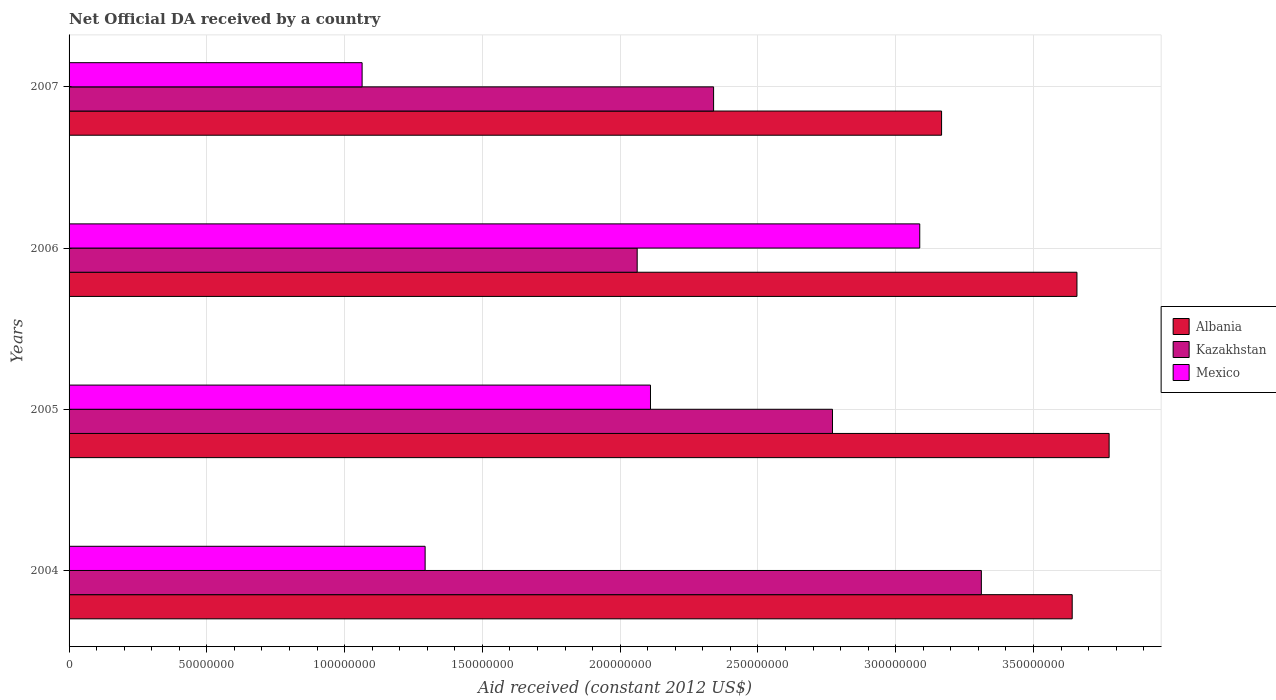Are the number of bars on each tick of the Y-axis equal?
Keep it short and to the point. Yes. In how many cases, is the number of bars for a given year not equal to the number of legend labels?
Provide a short and direct response. 0. What is the net official development assistance aid received in Albania in 2005?
Keep it short and to the point. 3.77e+08. Across all years, what is the maximum net official development assistance aid received in Mexico?
Provide a short and direct response. 3.09e+08. Across all years, what is the minimum net official development assistance aid received in Kazakhstan?
Provide a short and direct response. 2.06e+08. In which year was the net official development assistance aid received in Albania maximum?
Ensure brevity in your answer.  2005. What is the total net official development assistance aid received in Kazakhstan in the graph?
Your answer should be very brief. 1.05e+09. What is the difference between the net official development assistance aid received in Albania in 2006 and that in 2007?
Ensure brevity in your answer.  4.91e+07. What is the difference between the net official development assistance aid received in Kazakhstan in 2004 and the net official development assistance aid received in Mexico in 2005?
Provide a succinct answer. 1.20e+08. What is the average net official development assistance aid received in Kazakhstan per year?
Give a very brief answer. 2.62e+08. In the year 2004, what is the difference between the net official development assistance aid received in Albania and net official development assistance aid received in Mexico?
Offer a terse response. 2.35e+08. What is the ratio of the net official development assistance aid received in Mexico in 2006 to that in 2007?
Make the answer very short. 2.9. Is the net official development assistance aid received in Mexico in 2004 less than that in 2005?
Give a very brief answer. Yes. Is the difference between the net official development assistance aid received in Albania in 2005 and 2007 greater than the difference between the net official development assistance aid received in Mexico in 2005 and 2007?
Provide a short and direct response. No. What is the difference between the highest and the second highest net official development assistance aid received in Albania?
Keep it short and to the point. 1.17e+07. What is the difference between the highest and the lowest net official development assistance aid received in Albania?
Keep it short and to the point. 6.08e+07. In how many years, is the net official development assistance aid received in Albania greater than the average net official development assistance aid received in Albania taken over all years?
Offer a terse response. 3. Is the sum of the net official development assistance aid received in Mexico in 2004 and 2006 greater than the maximum net official development assistance aid received in Kazakhstan across all years?
Provide a short and direct response. Yes. What does the 3rd bar from the top in 2004 represents?
Provide a short and direct response. Albania. What does the 2nd bar from the bottom in 2006 represents?
Your answer should be very brief. Kazakhstan. How many bars are there?
Provide a succinct answer. 12. What is the difference between two consecutive major ticks on the X-axis?
Keep it short and to the point. 5.00e+07. Are the values on the major ticks of X-axis written in scientific E-notation?
Offer a very short reply. No. How many legend labels are there?
Offer a terse response. 3. What is the title of the graph?
Your answer should be very brief. Net Official DA received by a country. What is the label or title of the X-axis?
Provide a succinct answer. Aid received (constant 2012 US$). What is the Aid received (constant 2012 US$) of Albania in 2004?
Keep it short and to the point. 3.64e+08. What is the Aid received (constant 2012 US$) of Kazakhstan in 2004?
Your answer should be very brief. 3.31e+08. What is the Aid received (constant 2012 US$) in Mexico in 2004?
Ensure brevity in your answer.  1.29e+08. What is the Aid received (constant 2012 US$) of Albania in 2005?
Provide a short and direct response. 3.77e+08. What is the Aid received (constant 2012 US$) of Kazakhstan in 2005?
Offer a terse response. 2.77e+08. What is the Aid received (constant 2012 US$) in Mexico in 2005?
Your response must be concise. 2.11e+08. What is the Aid received (constant 2012 US$) in Albania in 2006?
Your answer should be very brief. 3.66e+08. What is the Aid received (constant 2012 US$) of Kazakhstan in 2006?
Provide a short and direct response. 2.06e+08. What is the Aid received (constant 2012 US$) of Mexico in 2006?
Keep it short and to the point. 3.09e+08. What is the Aid received (constant 2012 US$) of Albania in 2007?
Make the answer very short. 3.17e+08. What is the Aid received (constant 2012 US$) of Kazakhstan in 2007?
Your answer should be compact. 2.34e+08. What is the Aid received (constant 2012 US$) in Mexico in 2007?
Give a very brief answer. 1.06e+08. Across all years, what is the maximum Aid received (constant 2012 US$) in Albania?
Give a very brief answer. 3.77e+08. Across all years, what is the maximum Aid received (constant 2012 US$) in Kazakhstan?
Provide a short and direct response. 3.31e+08. Across all years, what is the maximum Aid received (constant 2012 US$) in Mexico?
Your answer should be very brief. 3.09e+08. Across all years, what is the minimum Aid received (constant 2012 US$) of Albania?
Provide a short and direct response. 3.17e+08. Across all years, what is the minimum Aid received (constant 2012 US$) of Kazakhstan?
Give a very brief answer. 2.06e+08. Across all years, what is the minimum Aid received (constant 2012 US$) in Mexico?
Provide a short and direct response. 1.06e+08. What is the total Aid received (constant 2012 US$) of Albania in the graph?
Offer a very short reply. 1.42e+09. What is the total Aid received (constant 2012 US$) of Kazakhstan in the graph?
Provide a succinct answer. 1.05e+09. What is the total Aid received (constant 2012 US$) of Mexico in the graph?
Keep it short and to the point. 7.55e+08. What is the difference between the Aid received (constant 2012 US$) of Albania in 2004 and that in 2005?
Offer a very short reply. -1.34e+07. What is the difference between the Aid received (constant 2012 US$) in Kazakhstan in 2004 and that in 2005?
Offer a very short reply. 5.40e+07. What is the difference between the Aid received (constant 2012 US$) of Mexico in 2004 and that in 2005?
Give a very brief answer. -8.18e+07. What is the difference between the Aid received (constant 2012 US$) of Albania in 2004 and that in 2006?
Make the answer very short. -1.72e+06. What is the difference between the Aid received (constant 2012 US$) in Kazakhstan in 2004 and that in 2006?
Provide a succinct answer. 1.25e+08. What is the difference between the Aid received (constant 2012 US$) of Mexico in 2004 and that in 2006?
Offer a very short reply. -1.80e+08. What is the difference between the Aid received (constant 2012 US$) in Albania in 2004 and that in 2007?
Offer a very short reply. 4.74e+07. What is the difference between the Aid received (constant 2012 US$) in Kazakhstan in 2004 and that in 2007?
Keep it short and to the point. 9.72e+07. What is the difference between the Aid received (constant 2012 US$) of Mexico in 2004 and that in 2007?
Give a very brief answer. 2.29e+07. What is the difference between the Aid received (constant 2012 US$) of Albania in 2005 and that in 2006?
Provide a succinct answer. 1.17e+07. What is the difference between the Aid received (constant 2012 US$) of Kazakhstan in 2005 and that in 2006?
Provide a short and direct response. 7.09e+07. What is the difference between the Aid received (constant 2012 US$) of Mexico in 2005 and that in 2006?
Ensure brevity in your answer.  -9.77e+07. What is the difference between the Aid received (constant 2012 US$) in Albania in 2005 and that in 2007?
Offer a terse response. 6.08e+07. What is the difference between the Aid received (constant 2012 US$) of Kazakhstan in 2005 and that in 2007?
Provide a succinct answer. 4.32e+07. What is the difference between the Aid received (constant 2012 US$) in Mexico in 2005 and that in 2007?
Your answer should be compact. 1.05e+08. What is the difference between the Aid received (constant 2012 US$) of Albania in 2006 and that in 2007?
Give a very brief answer. 4.91e+07. What is the difference between the Aid received (constant 2012 US$) of Kazakhstan in 2006 and that in 2007?
Provide a succinct answer. -2.77e+07. What is the difference between the Aid received (constant 2012 US$) in Mexico in 2006 and that in 2007?
Keep it short and to the point. 2.02e+08. What is the difference between the Aid received (constant 2012 US$) of Albania in 2004 and the Aid received (constant 2012 US$) of Kazakhstan in 2005?
Your answer should be compact. 8.70e+07. What is the difference between the Aid received (constant 2012 US$) in Albania in 2004 and the Aid received (constant 2012 US$) in Mexico in 2005?
Provide a succinct answer. 1.53e+08. What is the difference between the Aid received (constant 2012 US$) of Kazakhstan in 2004 and the Aid received (constant 2012 US$) of Mexico in 2005?
Provide a short and direct response. 1.20e+08. What is the difference between the Aid received (constant 2012 US$) of Albania in 2004 and the Aid received (constant 2012 US$) of Kazakhstan in 2006?
Your answer should be very brief. 1.58e+08. What is the difference between the Aid received (constant 2012 US$) of Albania in 2004 and the Aid received (constant 2012 US$) of Mexico in 2006?
Your answer should be compact. 5.53e+07. What is the difference between the Aid received (constant 2012 US$) of Kazakhstan in 2004 and the Aid received (constant 2012 US$) of Mexico in 2006?
Your answer should be compact. 2.24e+07. What is the difference between the Aid received (constant 2012 US$) in Albania in 2004 and the Aid received (constant 2012 US$) in Kazakhstan in 2007?
Give a very brief answer. 1.30e+08. What is the difference between the Aid received (constant 2012 US$) of Albania in 2004 and the Aid received (constant 2012 US$) of Mexico in 2007?
Offer a terse response. 2.58e+08. What is the difference between the Aid received (constant 2012 US$) of Kazakhstan in 2004 and the Aid received (constant 2012 US$) of Mexico in 2007?
Offer a terse response. 2.25e+08. What is the difference between the Aid received (constant 2012 US$) in Albania in 2005 and the Aid received (constant 2012 US$) in Kazakhstan in 2006?
Your response must be concise. 1.71e+08. What is the difference between the Aid received (constant 2012 US$) of Albania in 2005 and the Aid received (constant 2012 US$) of Mexico in 2006?
Provide a short and direct response. 6.87e+07. What is the difference between the Aid received (constant 2012 US$) in Kazakhstan in 2005 and the Aid received (constant 2012 US$) in Mexico in 2006?
Make the answer very short. -3.17e+07. What is the difference between the Aid received (constant 2012 US$) in Albania in 2005 and the Aid received (constant 2012 US$) in Kazakhstan in 2007?
Your response must be concise. 1.44e+08. What is the difference between the Aid received (constant 2012 US$) in Albania in 2005 and the Aid received (constant 2012 US$) in Mexico in 2007?
Ensure brevity in your answer.  2.71e+08. What is the difference between the Aid received (constant 2012 US$) of Kazakhstan in 2005 and the Aid received (constant 2012 US$) of Mexico in 2007?
Offer a terse response. 1.71e+08. What is the difference between the Aid received (constant 2012 US$) of Albania in 2006 and the Aid received (constant 2012 US$) of Kazakhstan in 2007?
Offer a terse response. 1.32e+08. What is the difference between the Aid received (constant 2012 US$) in Albania in 2006 and the Aid received (constant 2012 US$) in Mexico in 2007?
Provide a short and direct response. 2.59e+08. What is the difference between the Aid received (constant 2012 US$) in Kazakhstan in 2006 and the Aid received (constant 2012 US$) in Mexico in 2007?
Give a very brief answer. 9.98e+07. What is the average Aid received (constant 2012 US$) in Albania per year?
Provide a succinct answer. 3.56e+08. What is the average Aid received (constant 2012 US$) in Kazakhstan per year?
Make the answer very short. 2.62e+08. What is the average Aid received (constant 2012 US$) in Mexico per year?
Your answer should be very brief. 1.89e+08. In the year 2004, what is the difference between the Aid received (constant 2012 US$) in Albania and Aid received (constant 2012 US$) in Kazakhstan?
Your answer should be very brief. 3.30e+07. In the year 2004, what is the difference between the Aid received (constant 2012 US$) of Albania and Aid received (constant 2012 US$) of Mexico?
Keep it short and to the point. 2.35e+08. In the year 2004, what is the difference between the Aid received (constant 2012 US$) of Kazakhstan and Aid received (constant 2012 US$) of Mexico?
Offer a terse response. 2.02e+08. In the year 2005, what is the difference between the Aid received (constant 2012 US$) of Albania and Aid received (constant 2012 US$) of Kazakhstan?
Give a very brief answer. 1.00e+08. In the year 2005, what is the difference between the Aid received (constant 2012 US$) in Albania and Aid received (constant 2012 US$) in Mexico?
Offer a terse response. 1.66e+08. In the year 2005, what is the difference between the Aid received (constant 2012 US$) of Kazakhstan and Aid received (constant 2012 US$) of Mexico?
Offer a terse response. 6.60e+07. In the year 2006, what is the difference between the Aid received (constant 2012 US$) of Albania and Aid received (constant 2012 US$) of Kazakhstan?
Make the answer very short. 1.60e+08. In the year 2006, what is the difference between the Aid received (constant 2012 US$) in Albania and Aid received (constant 2012 US$) in Mexico?
Your answer should be compact. 5.70e+07. In the year 2006, what is the difference between the Aid received (constant 2012 US$) of Kazakhstan and Aid received (constant 2012 US$) of Mexico?
Provide a succinct answer. -1.03e+08. In the year 2007, what is the difference between the Aid received (constant 2012 US$) of Albania and Aid received (constant 2012 US$) of Kazakhstan?
Make the answer very short. 8.27e+07. In the year 2007, what is the difference between the Aid received (constant 2012 US$) in Albania and Aid received (constant 2012 US$) in Mexico?
Give a very brief answer. 2.10e+08. In the year 2007, what is the difference between the Aid received (constant 2012 US$) in Kazakhstan and Aid received (constant 2012 US$) in Mexico?
Make the answer very short. 1.28e+08. What is the ratio of the Aid received (constant 2012 US$) in Albania in 2004 to that in 2005?
Your answer should be compact. 0.96. What is the ratio of the Aid received (constant 2012 US$) in Kazakhstan in 2004 to that in 2005?
Provide a short and direct response. 1.2. What is the ratio of the Aid received (constant 2012 US$) in Mexico in 2004 to that in 2005?
Your answer should be very brief. 0.61. What is the ratio of the Aid received (constant 2012 US$) of Kazakhstan in 2004 to that in 2006?
Your response must be concise. 1.61. What is the ratio of the Aid received (constant 2012 US$) in Mexico in 2004 to that in 2006?
Offer a terse response. 0.42. What is the ratio of the Aid received (constant 2012 US$) in Albania in 2004 to that in 2007?
Give a very brief answer. 1.15. What is the ratio of the Aid received (constant 2012 US$) of Kazakhstan in 2004 to that in 2007?
Ensure brevity in your answer.  1.42. What is the ratio of the Aid received (constant 2012 US$) of Mexico in 2004 to that in 2007?
Ensure brevity in your answer.  1.22. What is the ratio of the Aid received (constant 2012 US$) of Albania in 2005 to that in 2006?
Provide a succinct answer. 1.03. What is the ratio of the Aid received (constant 2012 US$) in Kazakhstan in 2005 to that in 2006?
Your answer should be very brief. 1.34. What is the ratio of the Aid received (constant 2012 US$) of Mexico in 2005 to that in 2006?
Ensure brevity in your answer.  0.68. What is the ratio of the Aid received (constant 2012 US$) of Albania in 2005 to that in 2007?
Provide a succinct answer. 1.19. What is the ratio of the Aid received (constant 2012 US$) in Kazakhstan in 2005 to that in 2007?
Keep it short and to the point. 1.18. What is the ratio of the Aid received (constant 2012 US$) in Mexico in 2005 to that in 2007?
Give a very brief answer. 1.98. What is the ratio of the Aid received (constant 2012 US$) in Albania in 2006 to that in 2007?
Provide a short and direct response. 1.16. What is the ratio of the Aid received (constant 2012 US$) in Kazakhstan in 2006 to that in 2007?
Provide a short and direct response. 0.88. What is the ratio of the Aid received (constant 2012 US$) in Mexico in 2006 to that in 2007?
Provide a succinct answer. 2.9. What is the difference between the highest and the second highest Aid received (constant 2012 US$) of Albania?
Make the answer very short. 1.17e+07. What is the difference between the highest and the second highest Aid received (constant 2012 US$) in Kazakhstan?
Your response must be concise. 5.40e+07. What is the difference between the highest and the second highest Aid received (constant 2012 US$) in Mexico?
Provide a succinct answer. 9.77e+07. What is the difference between the highest and the lowest Aid received (constant 2012 US$) in Albania?
Provide a succinct answer. 6.08e+07. What is the difference between the highest and the lowest Aid received (constant 2012 US$) of Kazakhstan?
Your answer should be compact. 1.25e+08. What is the difference between the highest and the lowest Aid received (constant 2012 US$) in Mexico?
Your response must be concise. 2.02e+08. 